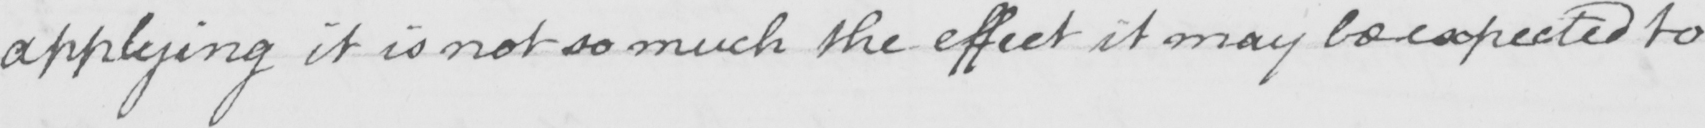Transcribe the text shown in this historical manuscript line. applying it is not so much the effect it may be expected to 